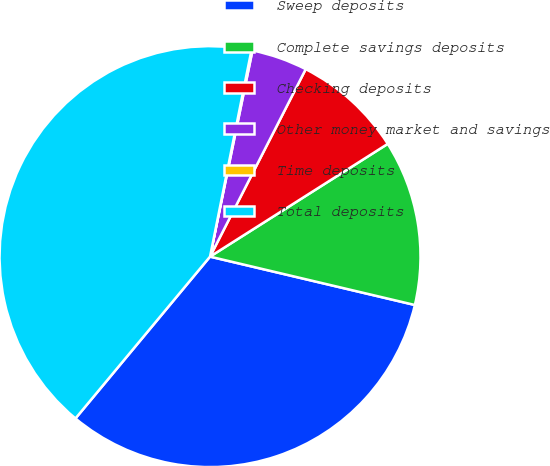Convert chart. <chart><loc_0><loc_0><loc_500><loc_500><pie_chart><fcel>Sweep deposits<fcel>Complete savings deposits<fcel>Checking deposits<fcel>Other money market and savings<fcel>Time deposits<fcel>Total deposits<nl><fcel>32.35%<fcel>12.69%<fcel>8.49%<fcel>4.28%<fcel>0.08%<fcel>42.11%<nl></chart> 